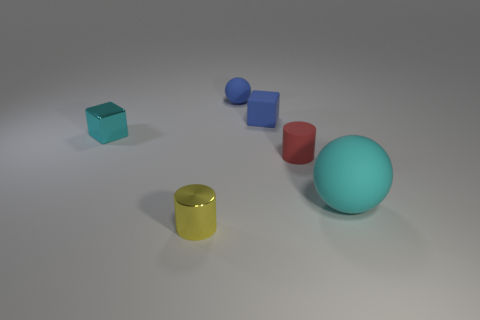What is the shape of the small matte thing that is the same color as the tiny rubber sphere?
Give a very brief answer. Cube. The other thing that is the same color as the large rubber thing is what size?
Provide a succinct answer. Small. There is a rubber ball to the right of the cylinder that is behind the small cylinder on the left side of the small blue matte cube; what size is it?
Give a very brief answer. Large. What number of other objects are there of the same shape as the red rubber object?
Keep it short and to the point. 1. What color is the tiny thing that is behind the metallic block and on the right side of the blue ball?
Offer a terse response. Blue. Is there anything else that is the same size as the yellow shiny cylinder?
Your answer should be very brief. Yes. Is the color of the tiny shiny thing to the right of the tiny cyan metal block the same as the shiny cube?
Your answer should be very brief. No. What number of blocks are yellow objects or big things?
Provide a short and direct response. 0. What shape is the cyan thing on the left side of the small blue ball?
Provide a short and direct response. Cube. The cylinder that is behind the tiny cylinder that is on the left side of the sphere that is behind the cyan metal block is what color?
Make the answer very short. Red. 